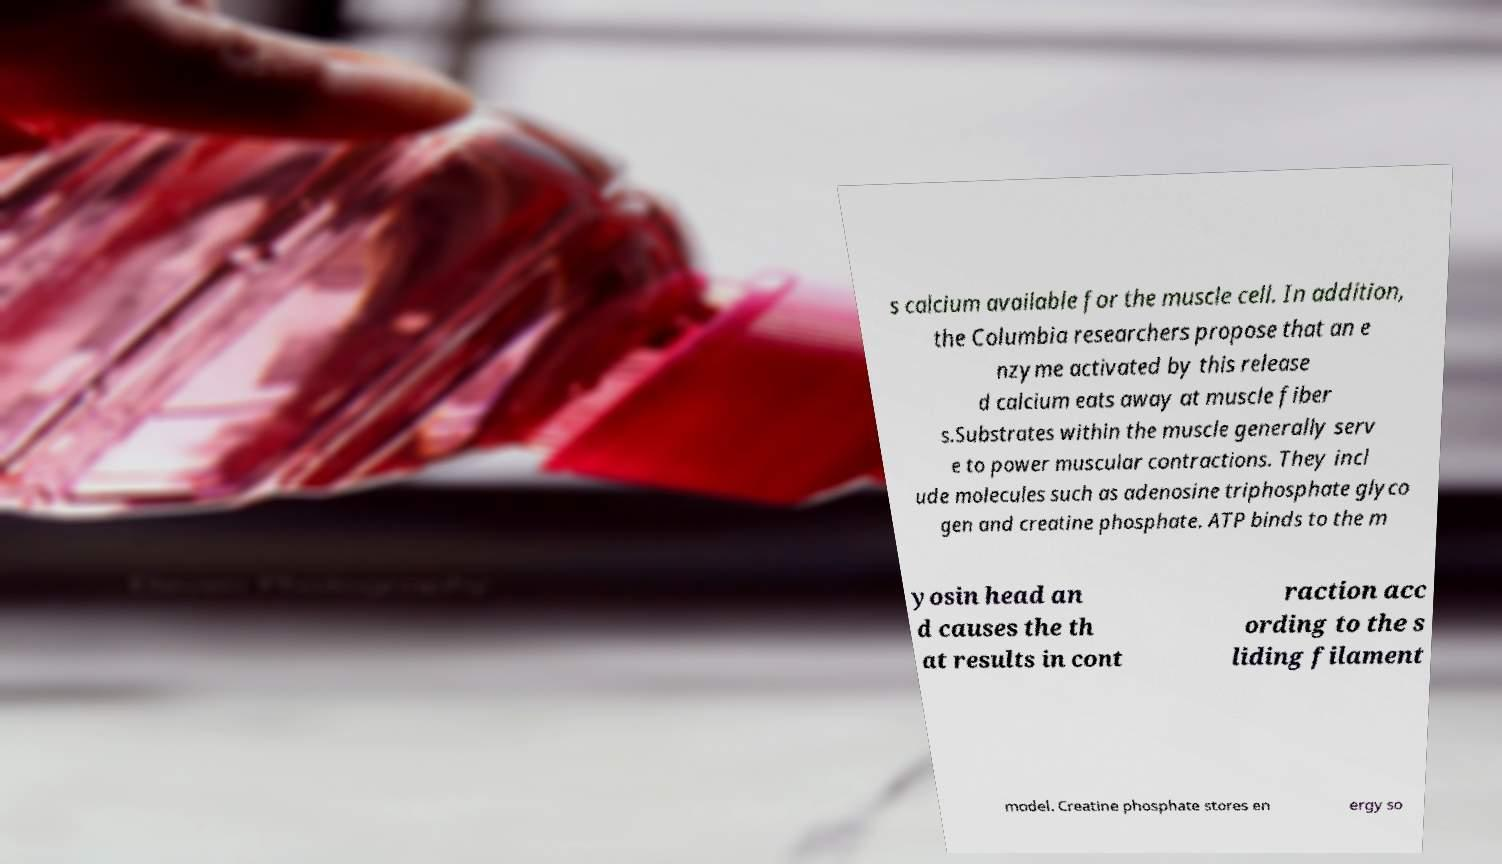Can you read and provide the text displayed in the image?This photo seems to have some interesting text. Can you extract and type it out for me? s calcium available for the muscle cell. In addition, the Columbia researchers propose that an e nzyme activated by this release d calcium eats away at muscle fiber s.Substrates within the muscle generally serv e to power muscular contractions. They incl ude molecules such as adenosine triphosphate glyco gen and creatine phosphate. ATP binds to the m yosin head an d causes the th at results in cont raction acc ording to the s liding filament model. Creatine phosphate stores en ergy so 